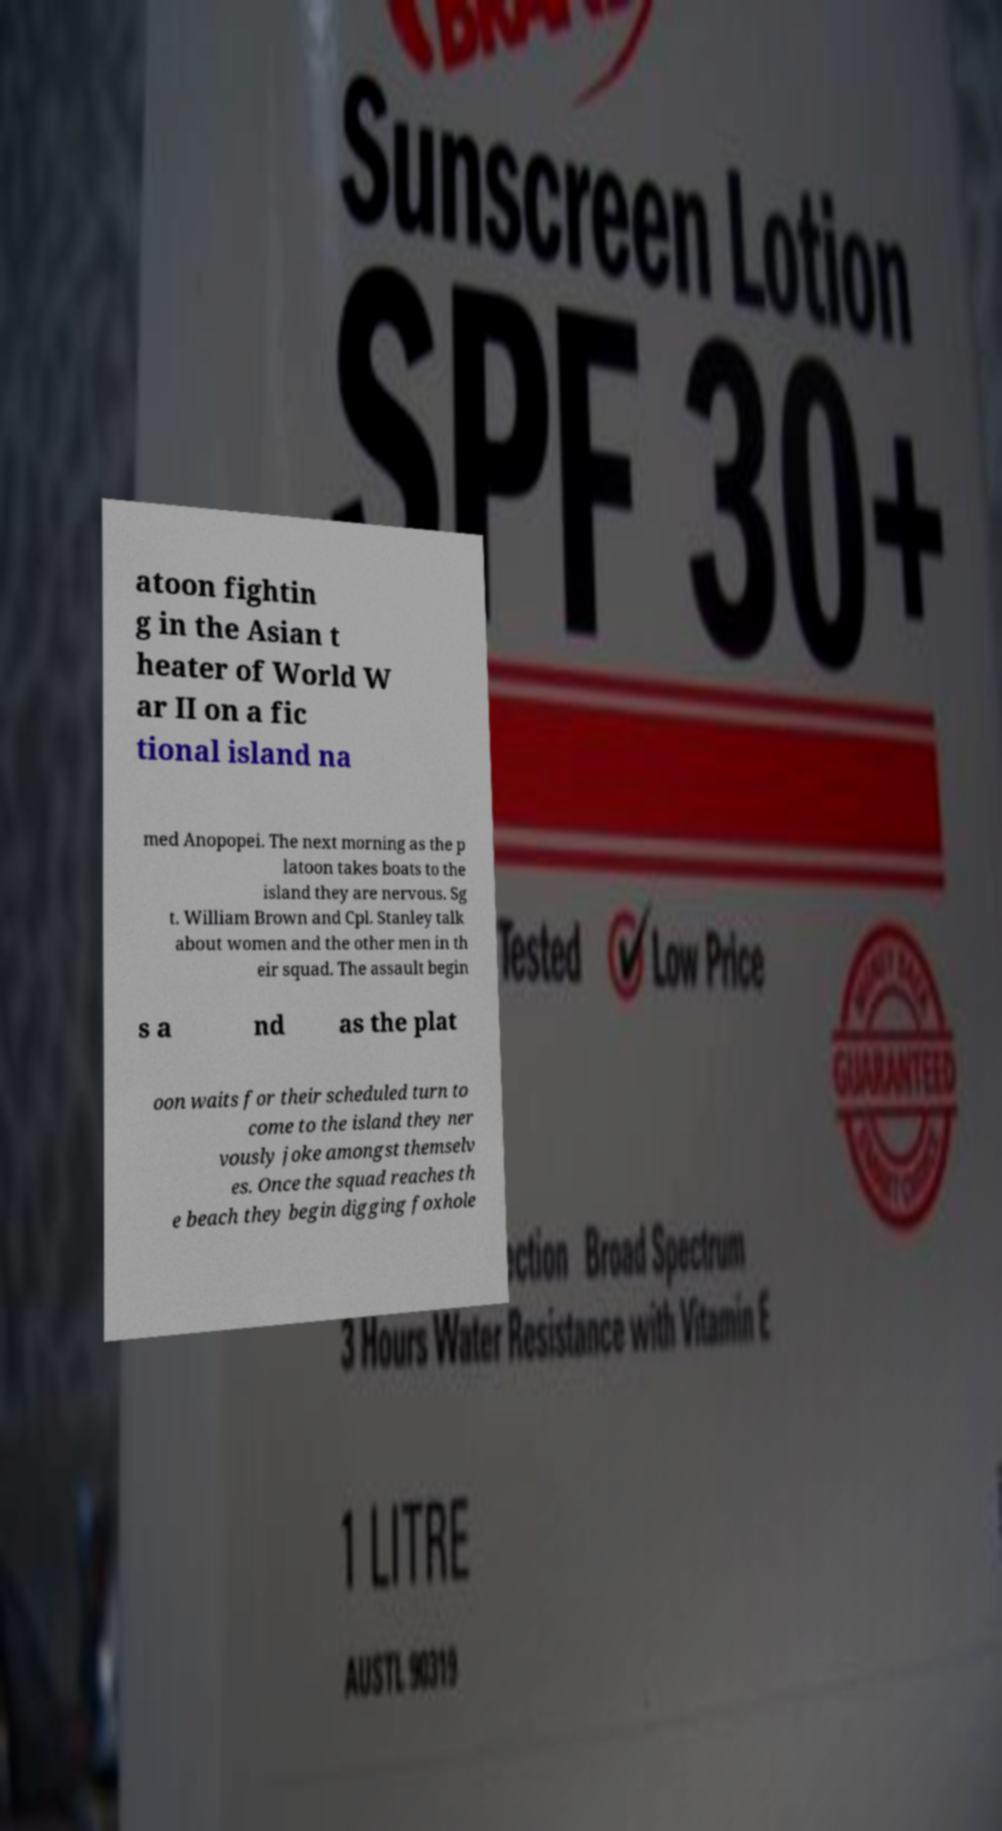I need the written content from this picture converted into text. Can you do that? atoon fightin g in the Asian t heater of World W ar II on a fic tional island na med Anopopei. The next morning as the p latoon takes boats to the island they are nervous. Sg t. William Brown and Cpl. Stanley talk about women and the other men in th eir squad. The assault begin s a nd as the plat oon waits for their scheduled turn to come to the island they ner vously joke amongst themselv es. Once the squad reaches th e beach they begin digging foxhole 